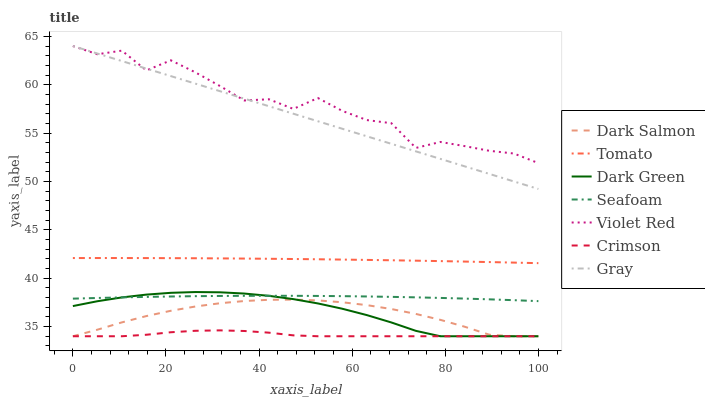Does Crimson have the minimum area under the curve?
Answer yes or no. Yes. Does Violet Red have the maximum area under the curve?
Answer yes or no. Yes. Does Gray have the minimum area under the curve?
Answer yes or no. No. Does Gray have the maximum area under the curve?
Answer yes or no. No. Is Gray the smoothest?
Answer yes or no. Yes. Is Violet Red the roughest?
Answer yes or no. Yes. Is Violet Red the smoothest?
Answer yes or no. No. Is Gray the roughest?
Answer yes or no. No. Does Dark Salmon have the lowest value?
Answer yes or no. Yes. Does Gray have the lowest value?
Answer yes or no. No. Does Violet Red have the highest value?
Answer yes or no. Yes. Does Seafoam have the highest value?
Answer yes or no. No. Is Dark Green less than Gray?
Answer yes or no. Yes. Is Violet Red greater than Seafoam?
Answer yes or no. Yes. Does Dark Salmon intersect Crimson?
Answer yes or no. Yes. Is Dark Salmon less than Crimson?
Answer yes or no. No. Is Dark Salmon greater than Crimson?
Answer yes or no. No. Does Dark Green intersect Gray?
Answer yes or no. No. 